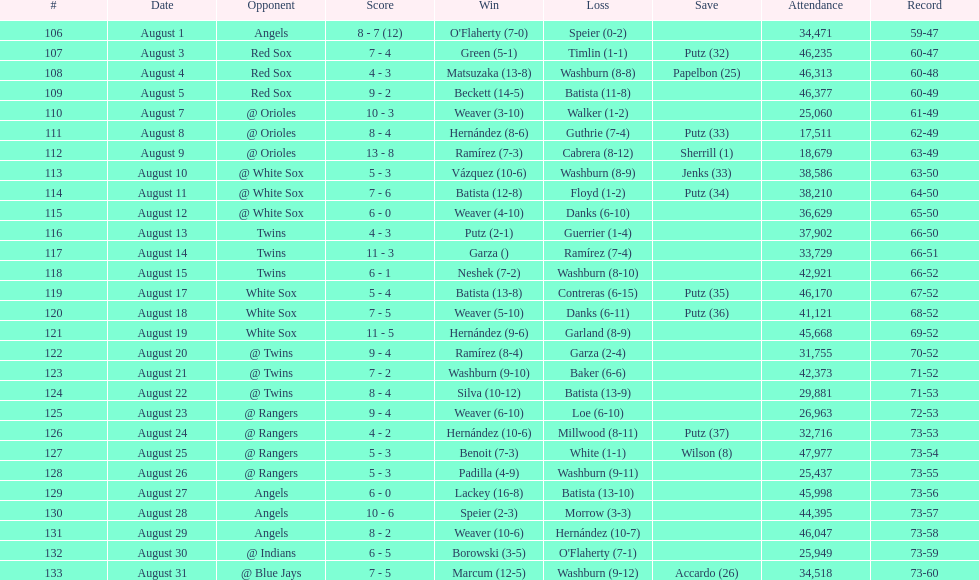In which games was the attendance more than 30,000 spectators? 21. 